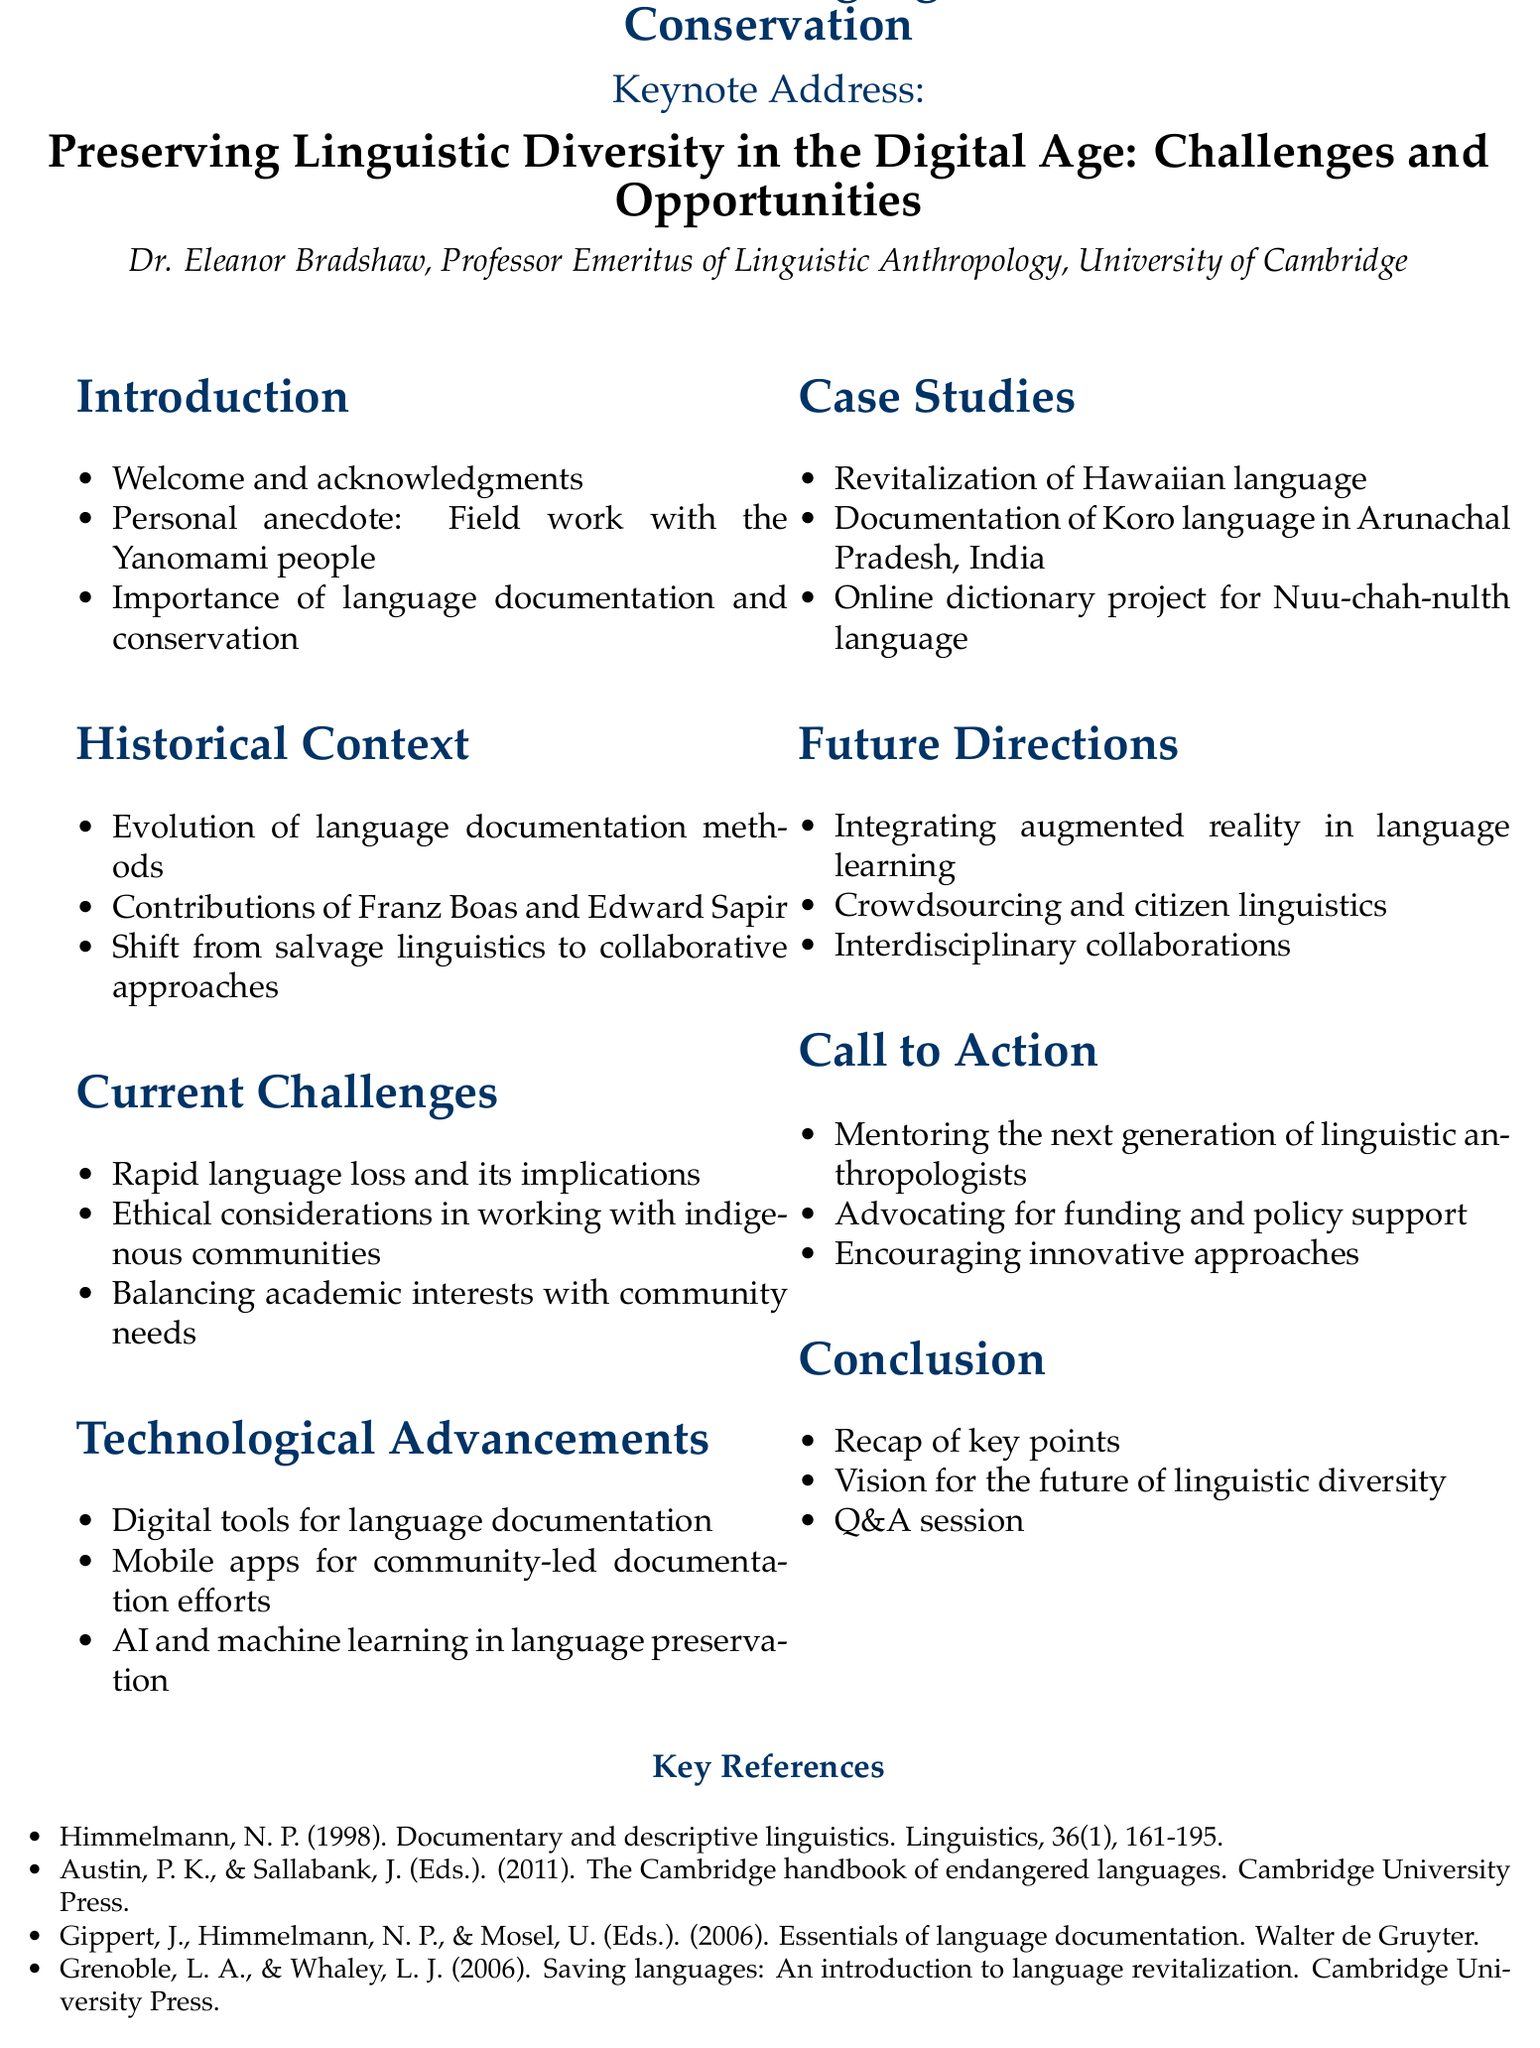What is the title of the keynote address? The title of the keynote address is provided in the document as "Preserving Linguistic Diversity in the Digital Age: Challenges and Opportunities."
Answer: Preserving Linguistic Diversity in the Digital Age: Challenges and Opportunities Who is the keynote speaker? The keynote speaker's name is noted in the document as Dr. Eleanor Bradshaw.
Answer: Dr. Eleanor Bradshaw What is one of the technological advancements mentioned? The document highlights digital tools for language documentation as a technological advancement.
Answer: Digital tools for language documentation How many case studies are presented? The document lists three specific case studies showcasing revitalization efforts and documentation.
Answer: Three What is the importance of mentoring emphasized in the call to action? The call to action section specifies the need for mentoring the next generation of linguistic anthropologists.
Answer: Mentoring the next generation of linguistic anthropologists What ethical consideration is mentioned in the current challenges? The ethical challenges addressed in the document include considerations in working with indigenous communities.
Answer: Ethical considerations in working with indigenous communities Name one key reference included in the document. The document contains several references, one of which is "Himmelmann, N. P. (1998). Documentary and descriptive linguistics."
Answer: Himmelmann, N. P. (1998). Documentary and descriptive linguistics What should the conclusion of the keynote address include? The conclusion will recap key points as described in the outline.
Answer: Recap of key points 